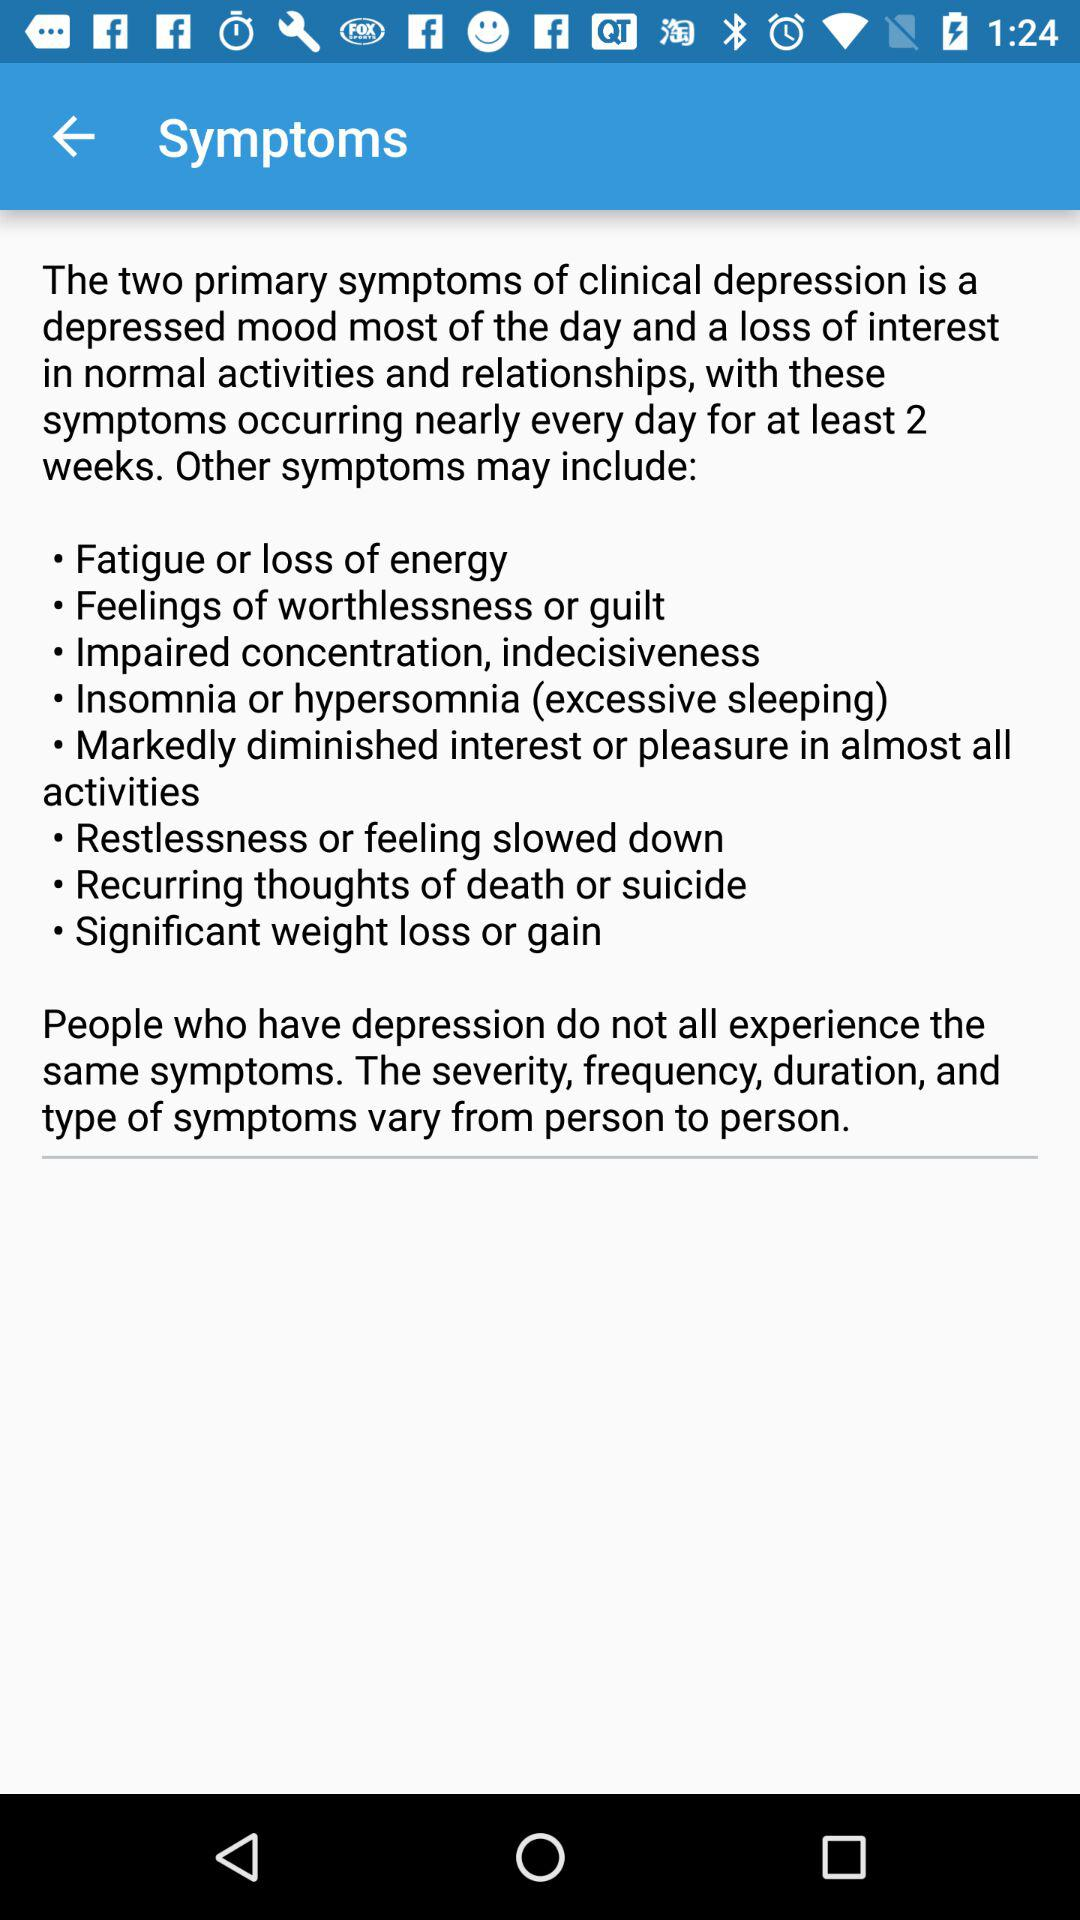How many symptoms are classified as primary?
Answer the question using a single word or phrase. 2 